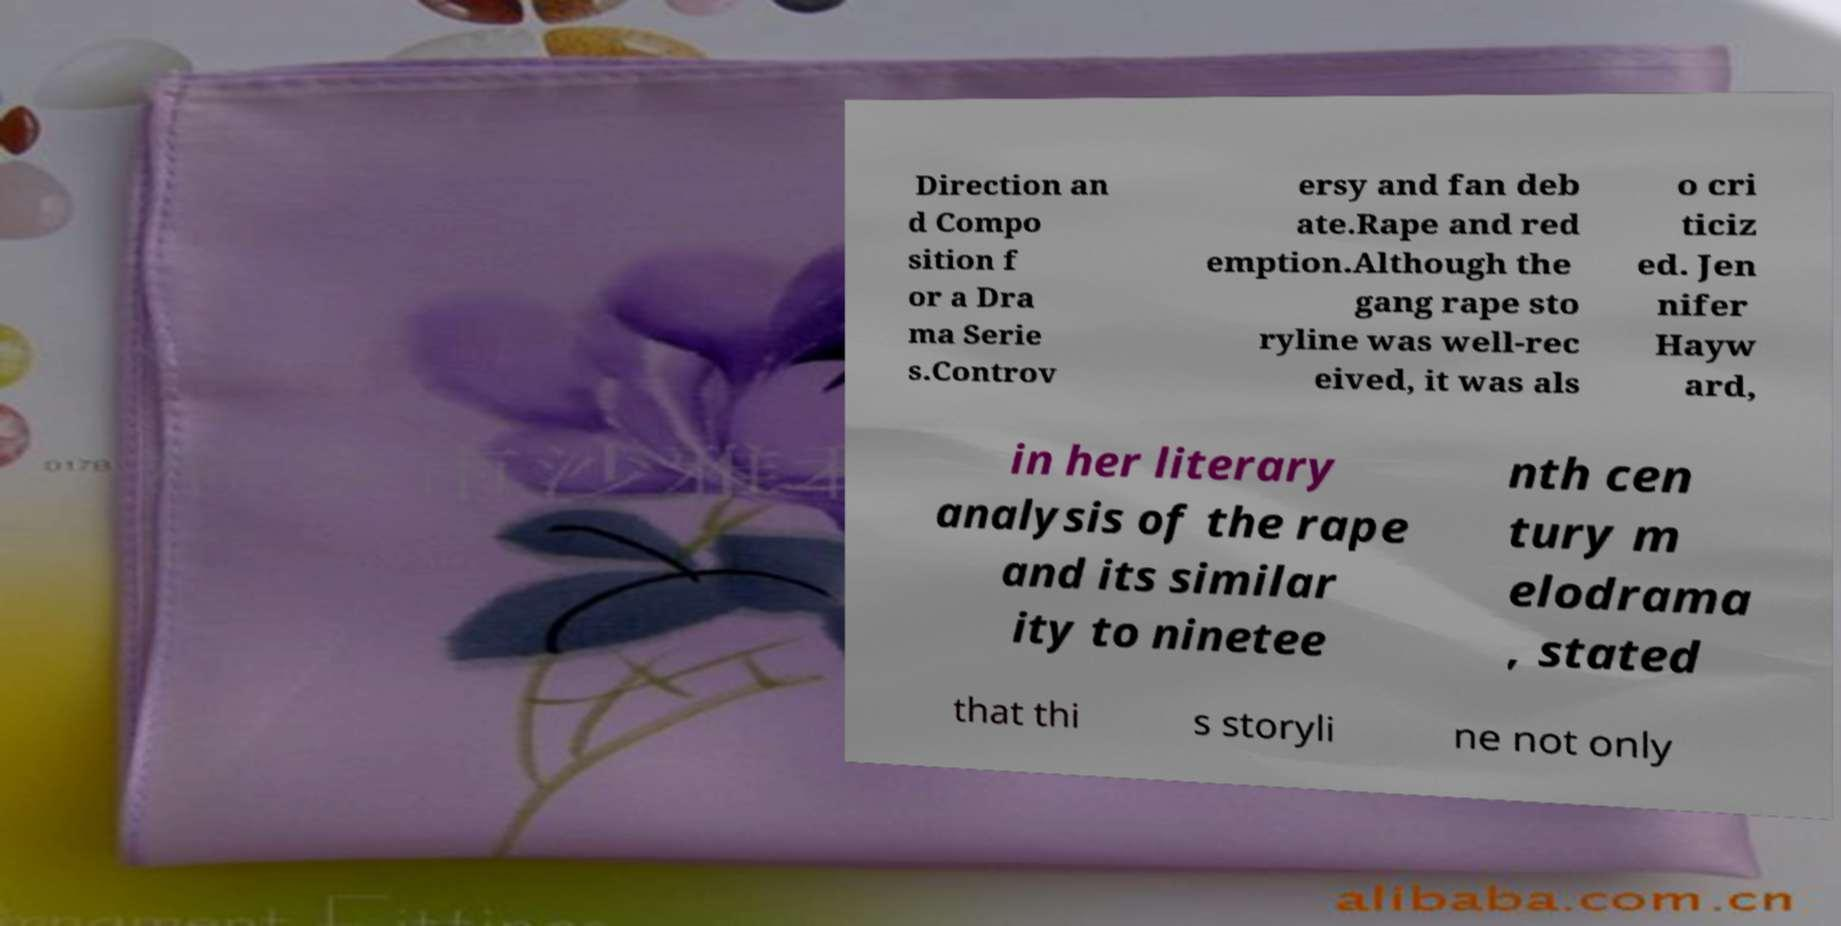For documentation purposes, I need the text within this image transcribed. Could you provide that? Direction an d Compo sition f or a Dra ma Serie s.Controv ersy and fan deb ate.Rape and red emption.Although the gang rape sto ryline was well-rec eived, it was als o cri ticiz ed. Jen nifer Hayw ard, in her literary analysis of the rape and its similar ity to ninetee nth cen tury m elodrama , stated that thi s storyli ne not only 